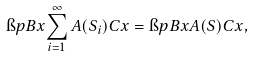<formula> <loc_0><loc_0><loc_500><loc_500>\i p { B x } { \sum _ { i = 1 } ^ { \infty } A ( S _ { i } ) C x } = \i p { B x } { A ( S ) C x } ,</formula> 